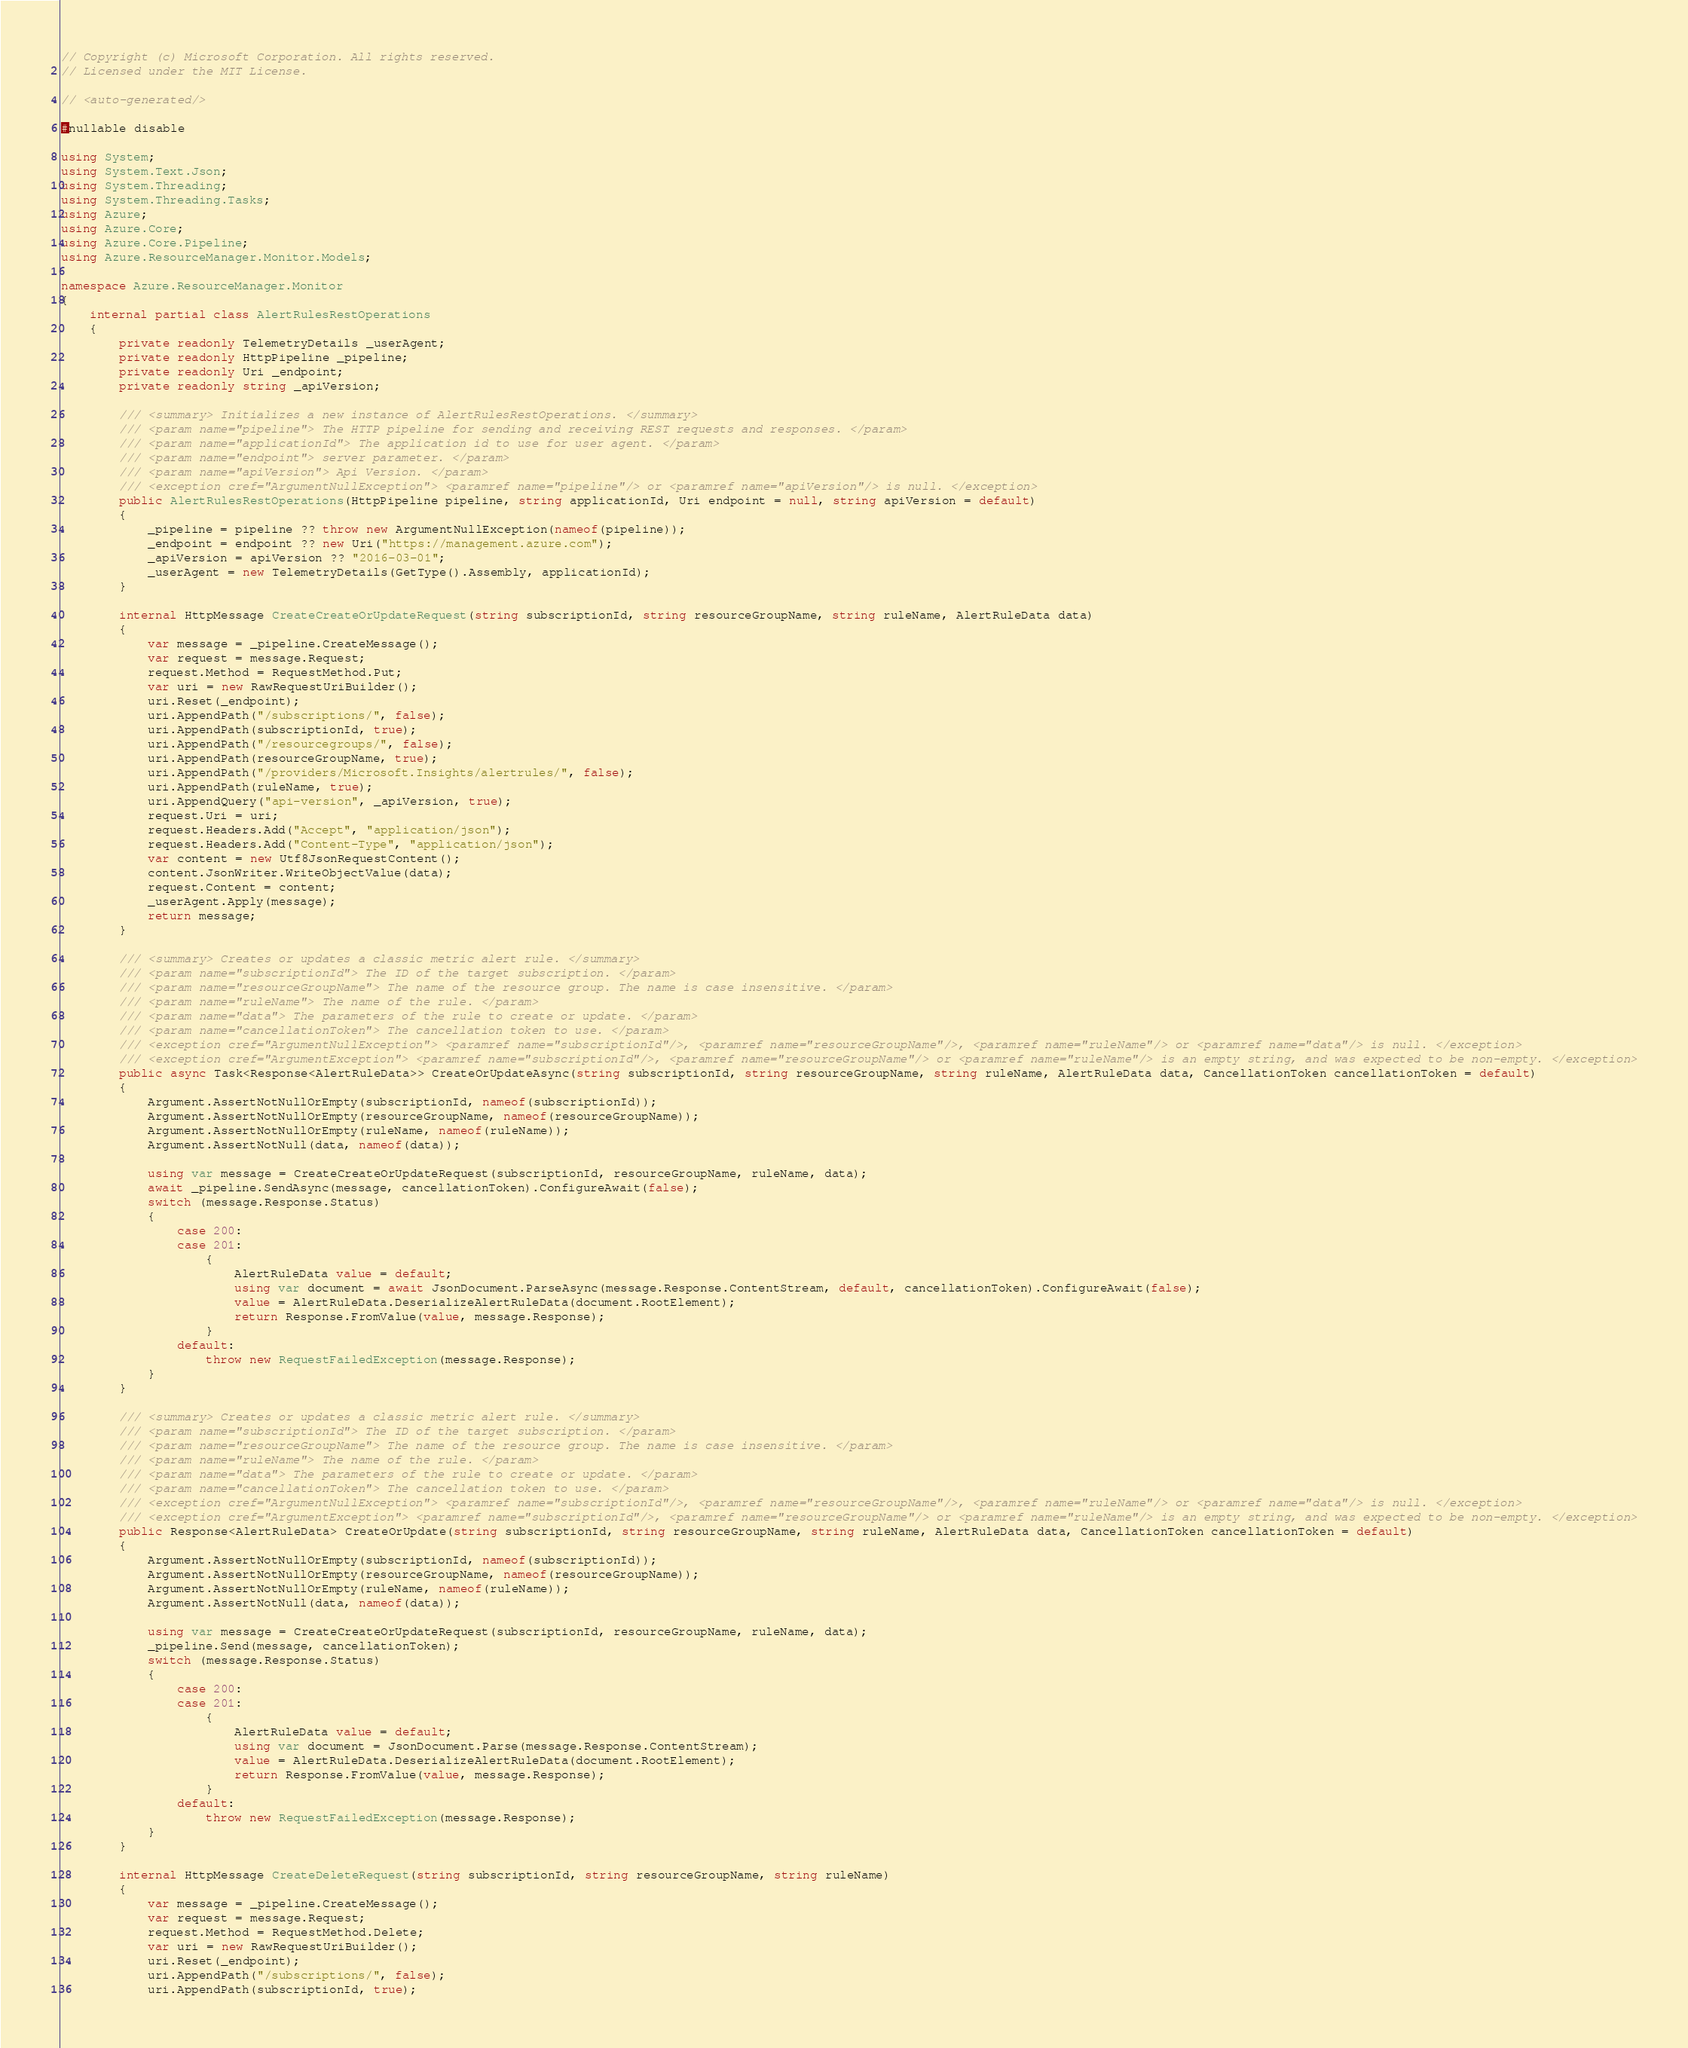<code> <loc_0><loc_0><loc_500><loc_500><_C#_>// Copyright (c) Microsoft Corporation. All rights reserved.
// Licensed under the MIT License.

// <auto-generated/>

#nullable disable

using System;
using System.Text.Json;
using System.Threading;
using System.Threading.Tasks;
using Azure;
using Azure.Core;
using Azure.Core.Pipeline;
using Azure.ResourceManager.Monitor.Models;

namespace Azure.ResourceManager.Monitor
{
    internal partial class AlertRulesRestOperations
    {
        private readonly TelemetryDetails _userAgent;
        private readonly HttpPipeline _pipeline;
        private readonly Uri _endpoint;
        private readonly string _apiVersion;

        /// <summary> Initializes a new instance of AlertRulesRestOperations. </summary>
        /// <param name="pipeline"> The HTTP pipeline for sending and receiving REST requests and responses. </param>
        /// <param name="applicationId"> The application id to use for user agent. </param>
        /// <param name="endpoint"> server parameter. </param>
        /// <param name="apiVersion"> Api Version. </param>
        /// <exception cref="ArgumentNullException"> <paramref name="pipeline"/> or <paramref name="apiVersion"/> is null. </exception>
        public AlertRulesRestOperations(HttpPipeline pipeline, string applicationId, Uri endpoint = null, string apiVersion = default)
        {
            _pipeline = pipeline ?? throw new ArgumentNullException(nameof(pipeline));
            _endpoint = endpoint ?? new Uri("https://management.azure.com");
            _apiVersion = apiVersion ?? "2016-03-01";
            _userAgent = new TelemetryDetails(GetType().Assembly, applicationId);
        }

        internal HttpMessage CreateCreateOrUpdateRequest(string subscriptionId, string resourceGroupName, string ruleName, AlertRuleData data)
        {
            var message = _pipeline.CreateMessage();
            var request = message.Request;
            request.Method = RequestMethod.Put;
            var uri = new RawRequestUriBuilder();
            uri.Reset(_endpoint);
            uri.AppendPath("/subscriptions/", false);
            uri.AppendPath(subscriptionId, true);
            uri.AppendPath("/resourcegroups/", false);
            uri.AppendPath(resourceGroupName, true);
            uri.AppendPath("/providers/Microsoft.Insights/alertrules/", false);
            uri.AppendPath(ruleName, true);
            uri.AppendQuery("api-version", _apiVersion, true);
            request.Uri = uri;
            request.Headers.Add("Accept", "application/json");
            request.Headers.Add("Content-Type", "application/json");
            var content = new Utf8JsonRequestContent();
            content.JsonWriter.WriteObjectValue(data);
            request.Content = content;
            _userAgent.Apply(message);
            return message;
        }

        /// <summary> Creates or updates a classic metric alert rule. </summary>
        /// <param name="subscriptionId"> The ID of the target subscription. </param>
        /// <param name="resourceGroupName"> The name of the resource group. The name is case insensitive. </param>
        /// <param name="ruleName"> The name of the rule. </param>
        /// <param name="data"> The parameters of the rule to create or update. </param>
        /// <param name="cancellationToken"> The cancellation token to use. </param>
        /// <exception cref="ArgumentNullException"> <paramref name="subscriptionId"/>, <paramref name="resourceGroupName"/>, <paramref name="ruleName"/> or <paramref name="data"/> is null. </exception>
        /// <exception cref="ArgumentException"> <paramref name="subscriptionId"/>, <paramref name="resourceGroupName"/> or <paramref name="ruleName"/> is an empty string, and was expected to be non-empty. </exception>
        public async Task<Response<AlertRuleData>> CreateOrUpdateAsync(string subscriptionId, string resourceGroupName, string ruleName, AlertRuleData data, CancellationToken cancellationToken = default)
        {
            Argument.AssertNotNullOrEmpty(subscriptionId, nameof(subscriptionId));
            Argument.AssertNotNullOrEmpty(resourceGroupName, nameof(resourceGroupName));
            Argument.AssertNotNullOrEmpty(ruleName, nameof(ruleName));
            Argument.AssertNotNull(data, nameof(data));

            using var message = CreateCreateOrUpdateRequest(subscriptionId, resourceGroupName, ruleName, data);
            await _pipeline.SendAsync(message, cancellationToken).ConfigureAwait(false);
            switch (message.Response.Status)
            {
                case 200:
                case 201:
                    {
                        AlertRuleData value = default;
                        using var document = await JsonDocument.ParseAsync(message.Response.ContentStream, default, cancellationToken).ConfigureAwait(false);
                        value = AlertRuleData.DeserializeAlertRuleData(document.RootElement);
                        return Response.FromValue(value, message.Response);
                    }
                default:
                    throw new RequestFailedException(message.Response);
            }
        }

        /// <summary> Creates or updates a classic metric alert rule. </summary>
        /// <param name="subscriptionId"> The ID of the target subscription. </param>
        /// <param name="resourceGroupName"> The name of the resource group. The name is case insensitive. </param>
        /// <param name="ruleName"> The name of the rule. </param>
        /// <param name="data"> The parameters of the rule to create or update. </param>
        /// <param name="cancellationToken"> The cancellation token to use. </param>
        /// <exception cref="ArgumentNullException"> <paramref name="subscriptionId"/>, <paramref name="resourceGroupName"/>, <paramref name="ruleName"/> or <paramref name="data"/> is null. </exception>
        /// <exception cref="ArgumentException"> <paramref name="subscriptionId"/>, <paramref name="resourceGroupName"/> or <paramref name="ruleName"/> is an empty string, and was expected to be non-empty. </exception>
        public Response<AlertRuleData> CreateOrUpdate(string subscriptionId, string resourceGroupName, string ruleName, AlertRuleData data, CancellationToken cancellationToken = default)
        {
            Argument.AssertNotNullOrEmpty(subscriptionId, nameof(subscriptionId));
            Argument.AssertNotNullOrEmpty(resourceGroupName, nameof(resourceGroupName));
            Argument.AssertNotNullOrEmpty(ruleName, nameof(ruleName));
            Argument.AssertNotNull(data, nameof(data));

            using var message = CreateCreateOrUpdateRequest(subscriptionId, resourceGroupName, ruleName, data);
            _pipeline.Send(message, cancellationToken);
            switch (message.Response.Status)
            {
                case 200:
                case 201:
                    {
                        AlertRuleData value = default;
                        using var document = JsonDocument.Parse(message.Response.ContentStream);
                        value = AlertRuleData.DeserializeAlertRuleData(document.RootElement);
                        return Response.FromValue(value, message.Response);
                    }
                default:
                    throw new RequestFailedException(message.Response);
            }
        }

        internal HttpMessage CreateDeleteRequest(string subscriptionId, string resourceGroupName, string ruleName)
        {
            var message = _pipeline.CreateMessage();
            var request = message.Request;
            request.Method = RequestMethod.Delete;
            var uri = new RawRequestUriBuilder();
            uri.Reset(_endpoint);
            uri.AppendPath("/subscriptions/", false);
            uri.AppendPath(subscriptionId, true);</code> 